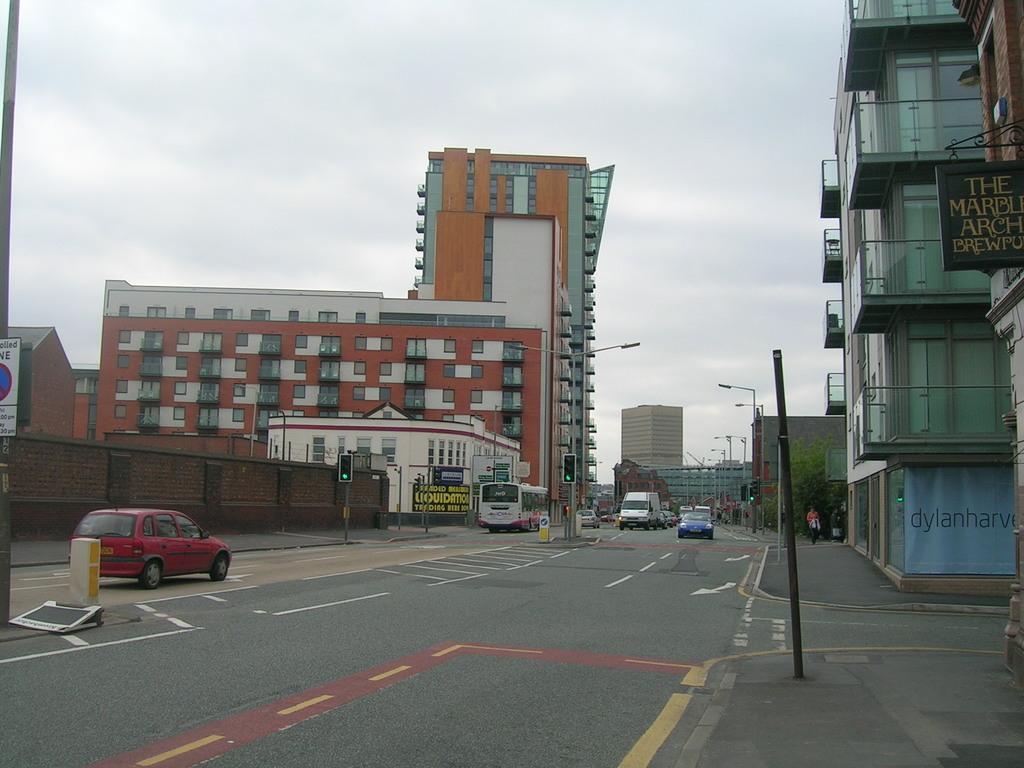Describe this image in one or two sentences. In this picture we can see vehicles on the road, poles, boards, traffic signals, lights, buildings and leaves. In the background of the image we can see the sky. 